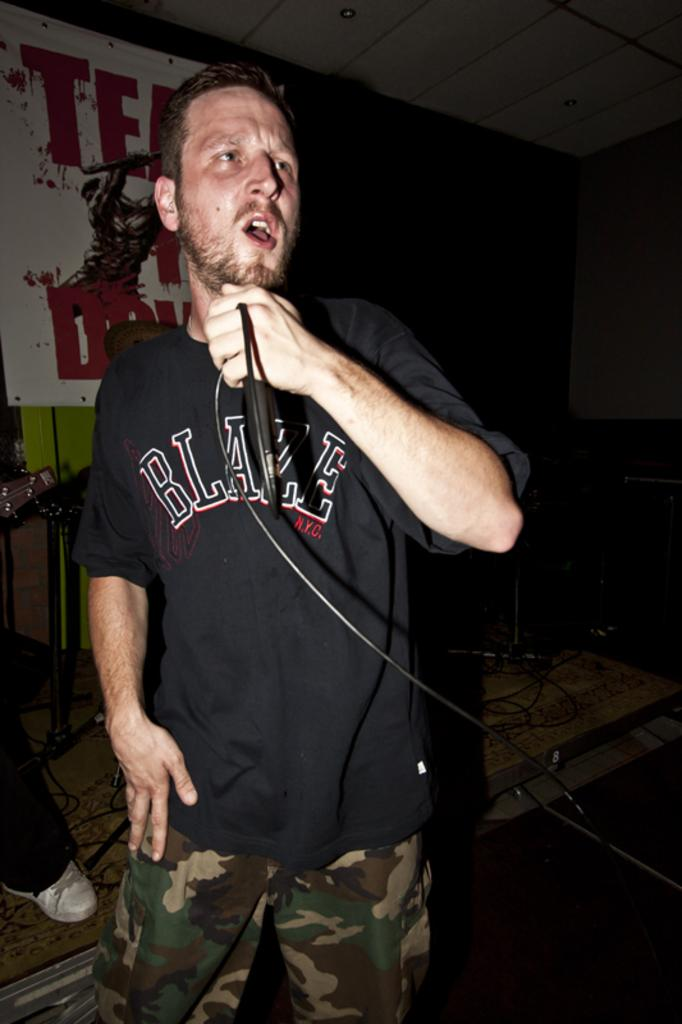What is the main subject of the image? There is a person in the image. What is the person holding in his hand? The person is holding a mic in his hand. What can be seen in the background of the image? There is a banner in the background of the image. What color is the blood on the side of the bed in the image? There is no blood or bed present in the image; it features a person holding a mic with a banner in the background. 